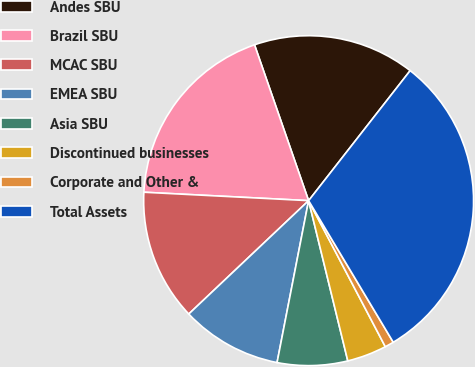<chart> <loc_0><loc_0><loc_500><loc_500><pie_chart><fcel>Andes SBU<fcel>Brazil SBU<fcel>MCAC SBU<fcel>EMEA SBU<fcel>Asia SBU<fcel>Discontinued businesses<fcel>Corporate and Other &<fcel>Total Assets<nl><fcel>15.87%<fcel>18.87%<fcel>12.87%<fcel>9.88%<fcel>6.88%<fcel>3.88%<fcel>0.88%<fcel>30.87%<nl></chart> 